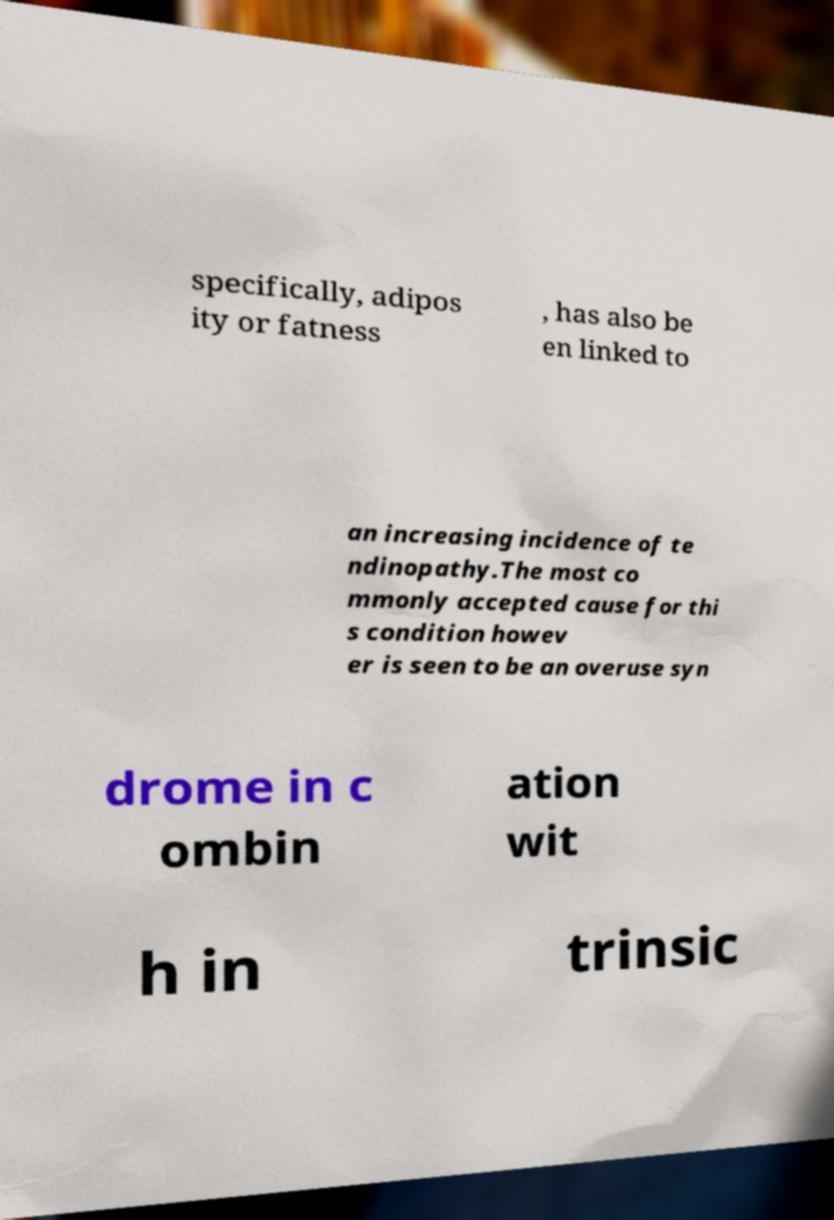Please identify and transcribe the text found in this image. specifically, adipos ity or fatness , has also be en linked to an increasing incidence of te ndinopathy.The most co mmonly accepted cause for thi s condition howev er is seen to be an overuse syn drome in c ombin ation wit h in trinsic 